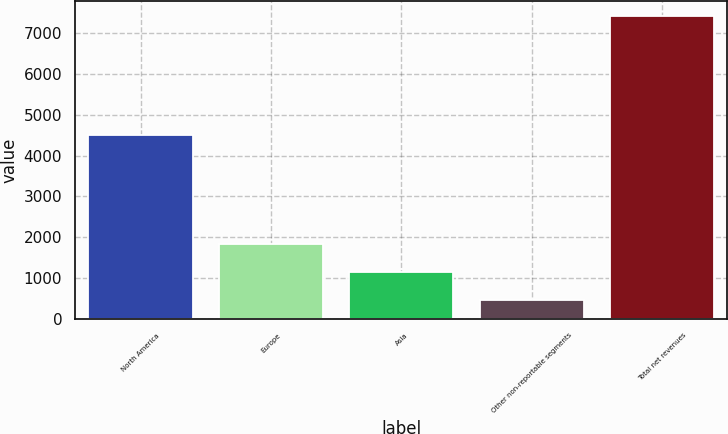Convert chart to OTSL. <chart><loc_0><loc_0><loc_500><loc_500><bar_chart><fcel>North America<fcel>Europe<fcel>Asia<fcel>Other non-reportable segments<fcel>Total net revenues<nl><fcel>4493.9<fcel>1845.84<fcel>1150.92<fcel>456<fcel>7405.2<nl></chart> 